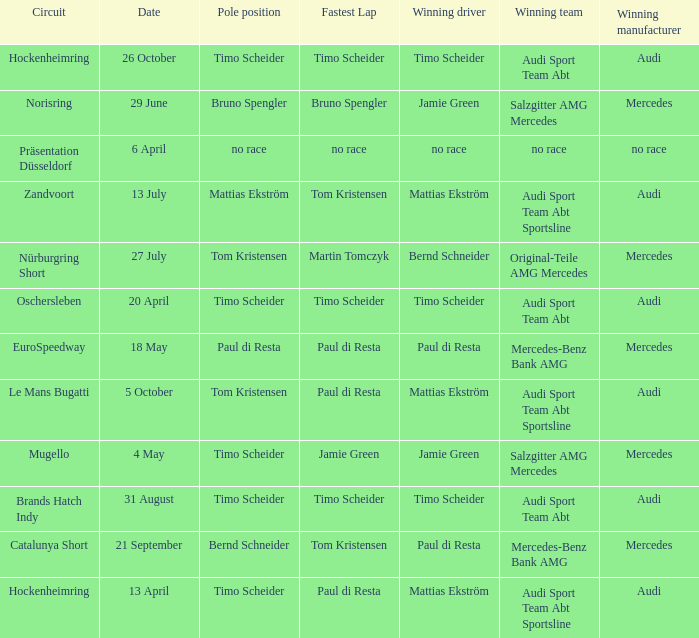What is the fastest lap in the Le Mans Bugatti circuit? Paul di Resta. 